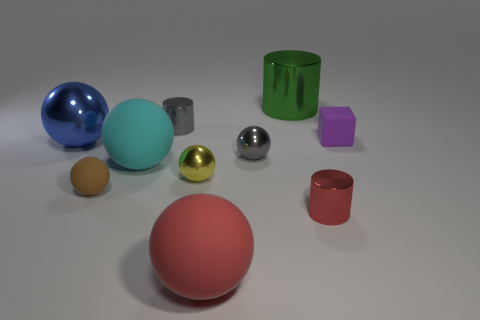Is there a tiny purple object made of the same material as the large green thing?
Provide a short and direct response. No. There is a object on the right side of the metallic cylinder that is in front of the purple rubber thing; how big is it?
Keep it short and to the point. Small. Is the number of tiny matte objects greater than the number of tiny yellow metal things?
Offer a very short reply. Yes. There is a metal ball that is on the left side of the gray cylinder; does it have the same size as the large red matte thing?
Your response must be concise. Yes. How many large balls have the same color as the cube?
Give a very brief answer. 0. Is the shape of the brown matte object the same as the small purple rubber thing?
Make the answer very short. No. Is there anything else that has the same size as the blue metal object?
Ensure brevity in your answer.  Yes. There is a red thing that is the same shape as the cyan object; what is its size?
Provide a succinct answer. Large. Is the number of green cylinders in front of the small red metal cylinder greater than the number of small red shiny cylinders that are behind the yellow metal thing?
Your response must be concise. No. Do the brown thing and the large thing on the left side of the large cyan matte object have the same material?
Your answer should be compact. No. 